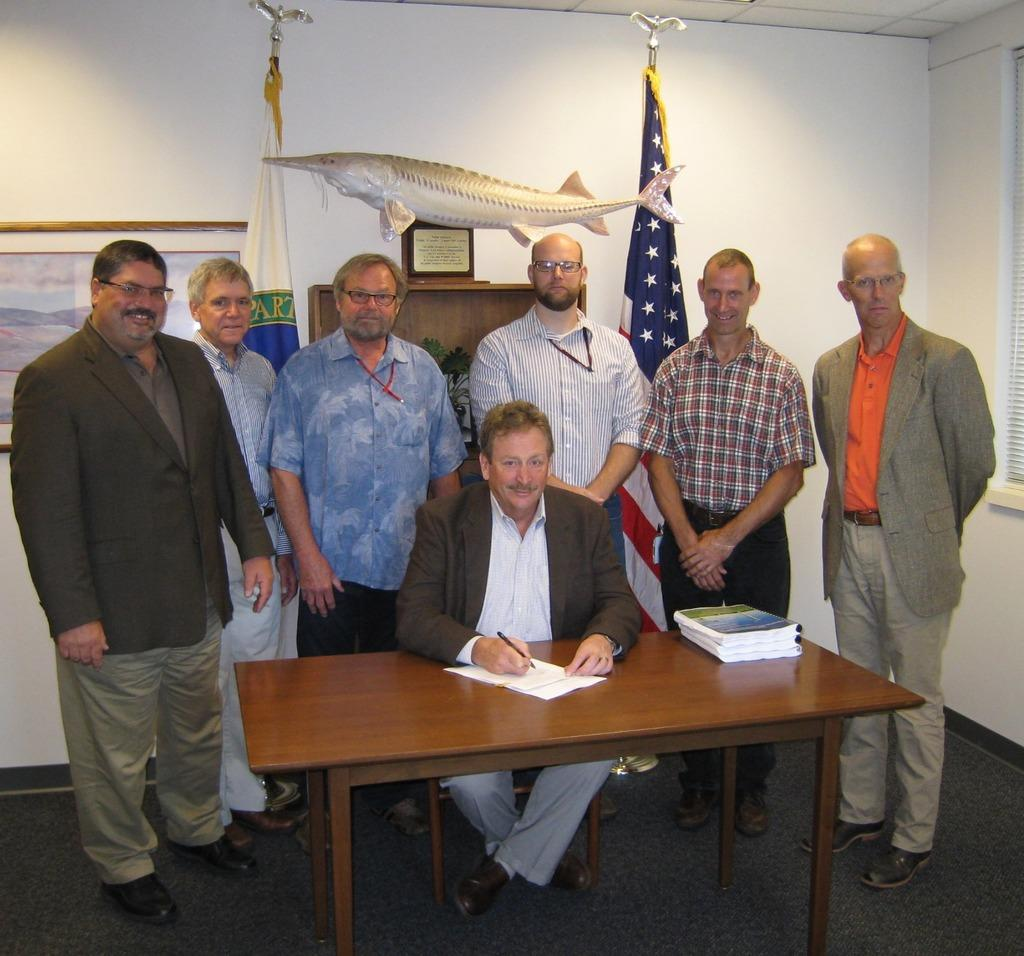What is the color of the wall in the image? The wall in the image is white. Who or what can be seen in the image? There are people in the image. What piece of furniture is present in the image? There is a table in the image. What is placed on the table in the image? There is a paper and books on the table. What type of pipe is being smoked by the person in the image? There is no person smoking a pipe in the image. 